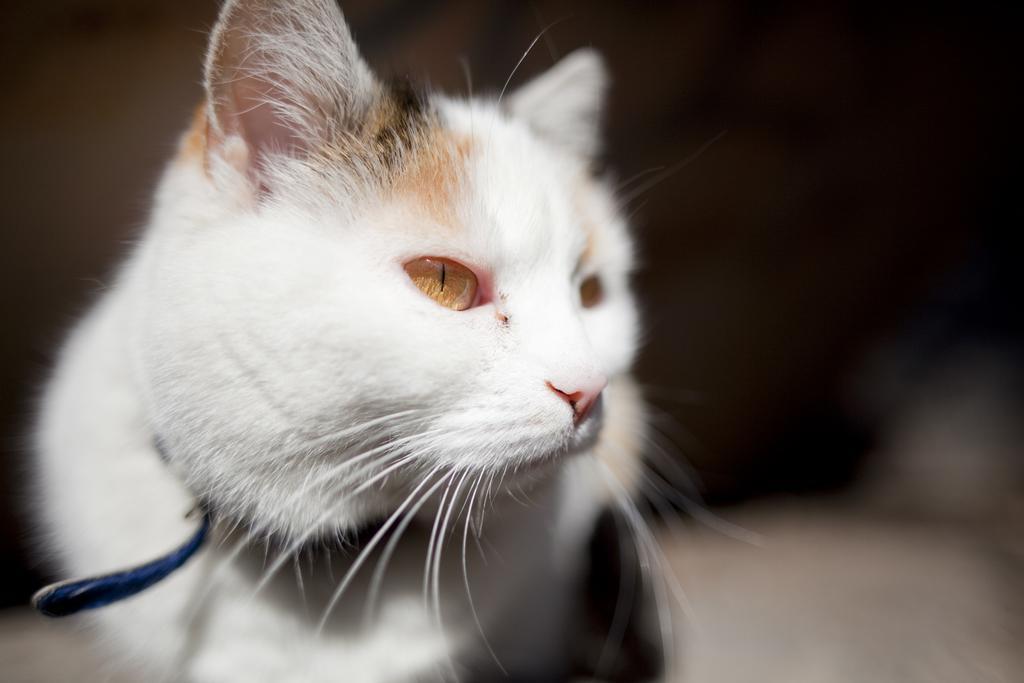In one or two sentences, can you explain what this image depicts? In this image we can see a white cat and the background is blurred. 